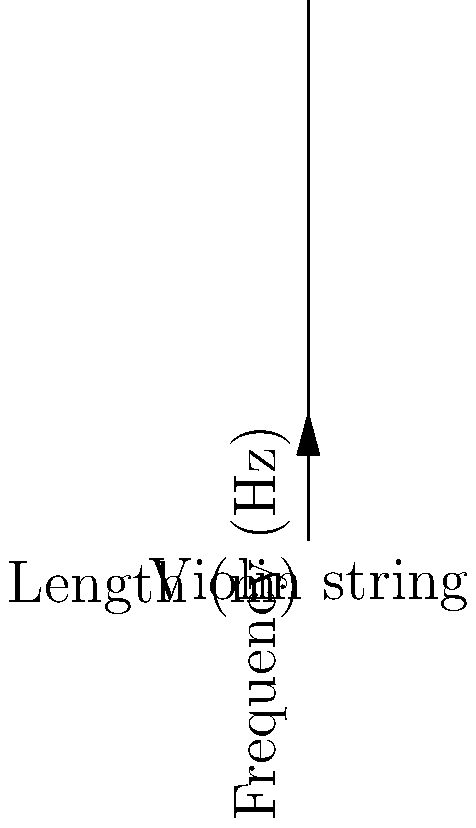A violin string vibrates at 440 Hz when its length is 0.33 meters. If the string is shortened to 0.22 meters, what will be its new frequency? Assume the tension and linear density of the string remain constant. To solve this problem, we'll use the relationship between frequency and string length:

1) The frequency of a vibrating string is inversely proportional to its length. We can express this as:

   $$f_1 L_1 = f_2 L_2$$

   Where $f$ is frequency and $L$ is length, and the subscripts 1 and 2 represent the initial and final states.

2) We know:
   $f_1 = 440$ Hz
   $L_1 = 0.33$ m
   $L_2 = 0.22$ m
   
   We need to find $f_2$

3) Substituting into our equation:

   $$440 \times 0.33 = f_2 \times 0.22$$

4) Solving for $f_2$:

   $$f_2 = \frac{440 \times 0.33}{0.22}$$

5) Calculate:

   $$f_2 = 660 \text{ Hz}$$

Therefore, the new frequency of the shortened string will be 660 Hz.
Answer: 660 Hz 